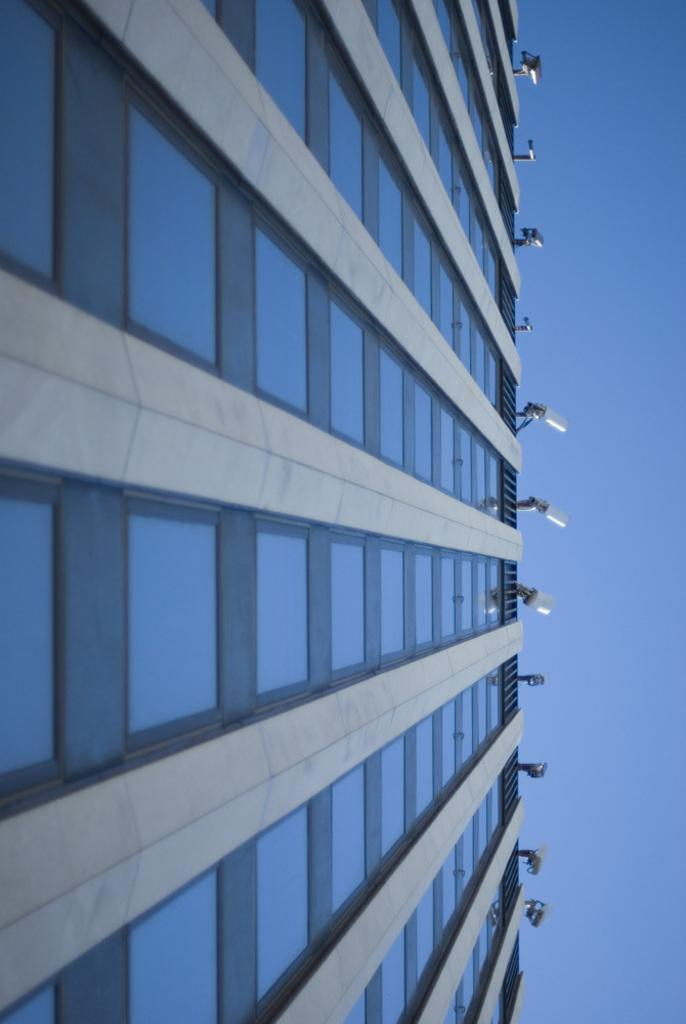What is the main structure in the image? There is a building in the image. What feature of the building is mentioned in the facts? The building has lights on it. What part of the natural environment is visible in the image? The sky is visible on the right side of the image. What type of twig can be seen on the roof of the building in the image? There is no twig present on the roof of the building in the image. How many rails are visible near the building in the image? There is no rail visible near the building in the image. 